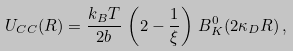<formula> <loc_0><loc_0><loc_500><loc_500>U _ { C C } ( R ) = \frac { k _ { B } T } { 2 b } \, \left ( 2 - \frac { 1 } { \xi } \right ) \, B ^ { 0 } _ { K } ( 2 \kappa _ { D } R ) \, ,</formula> 